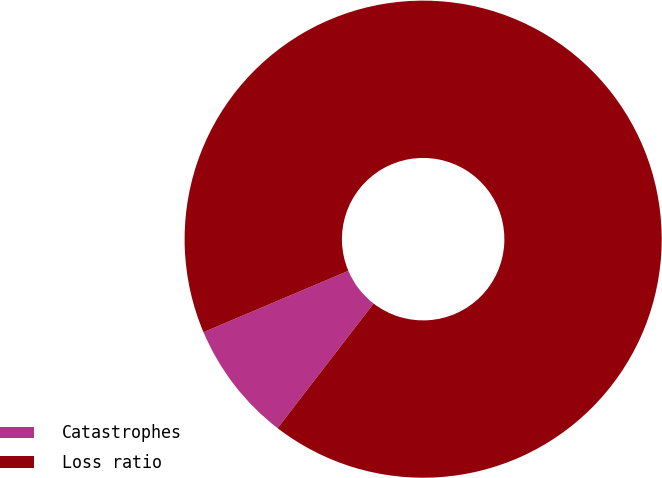Convert chart to OTSL. <chart><loc_0><loc_0><loc_500><loc_500><pie_chart><fcel>Catastrophes<fcel>Loss ratio<nl><fcel>8.18%<fcel>91.82%<nl></chart> 